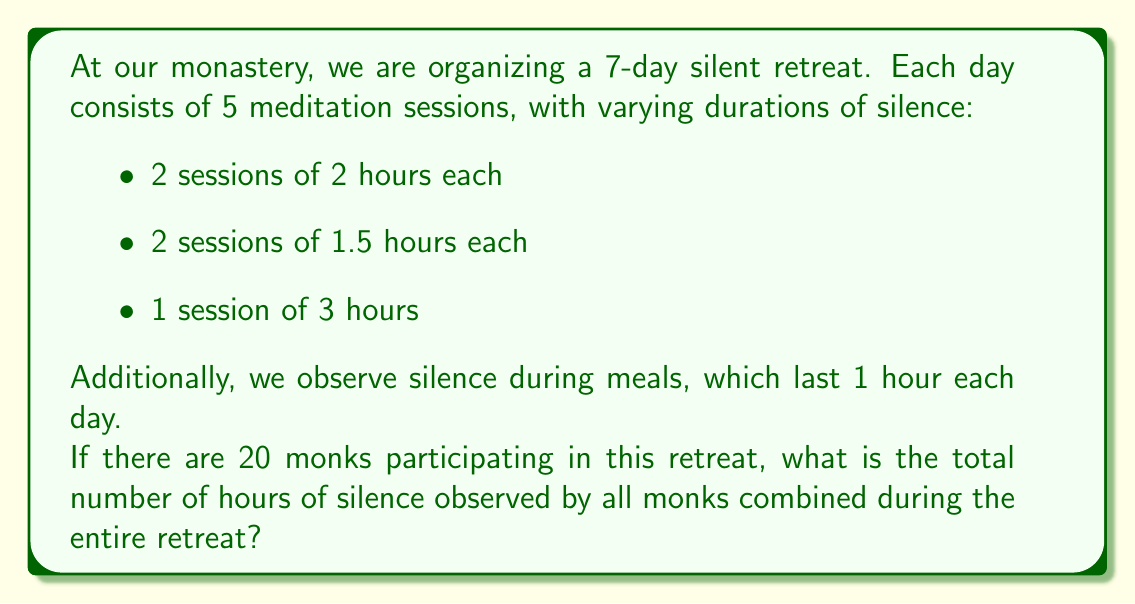Show me your answer to this math problem. Let's break this problem down step by step:

1. Calculate the total hours of silence per day for one monk:
   $$2 \times 2 + 2 \times 1.5 + 1 \times 3 + 1 = 10$$ hours

2. Calculate the total hours of silence for one monk during the entire retreat:
   $$10 \text{ hours} \times 7 \text{ days} = 70$$ hours

3. Calculate the total hours of silence for all monks:
   $$70 \text{ hours} \times 20 \text{ monks} = 1400$$ hours

Therefore, the total number of hours of silence observed by all monks combined during the entire retreat is 1400 hours.
Answer: 1400 hours 